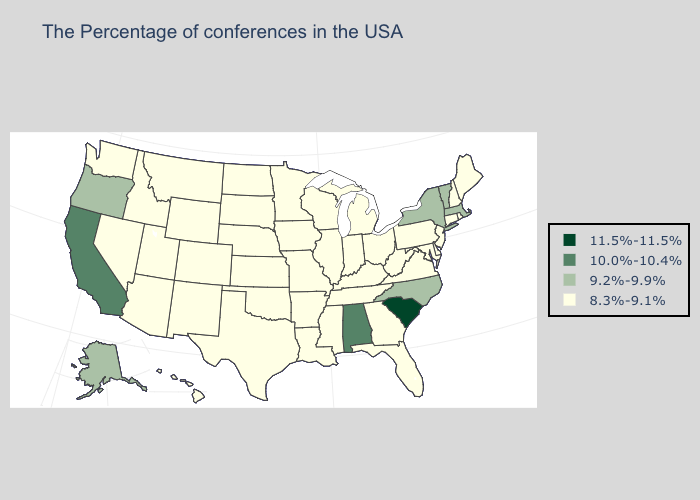What is the lowest value in the USA?
Answer briefly. 8.3%-9.1%. What is the value of Kentucky?
Answer briefly. 8.3%-9.1%. Does the map have missing data?
Be succinct. No. Does Oklahoma have the highest value in the South?
Quick response, please. No. Name the states that have a value in the range 10.0%-10.4%?
Short answer required. Alabama, California. What is the lowest value in the West?
Keep it brief. 8.3%-9.1%. Does Utah have a lower value than Maine?
Quick response, please. No. Does Montana have the highest value in the West?
Give a very brief answer. No. What is the value of West Virginia?
Give a very brief answer. 8.3%-9.1%. Does Ohio have the highest value in the USA?
Short answer required. No. Which states hav the highest value in the MidWest?
Concise answer only. Ohio, Michigan, Indiana, Wisconsin, Illinois, Missouri, Minnesota, Iowa, Kansas, Nebraska, South Dakota, North Dakota. Does the map have missing data?
Short answer required. No. What is the highest value in the USA?
Quick response, please. 11.5%-11.5%. Does California have the lowest value in the USA?
Write a very short answer. No. 